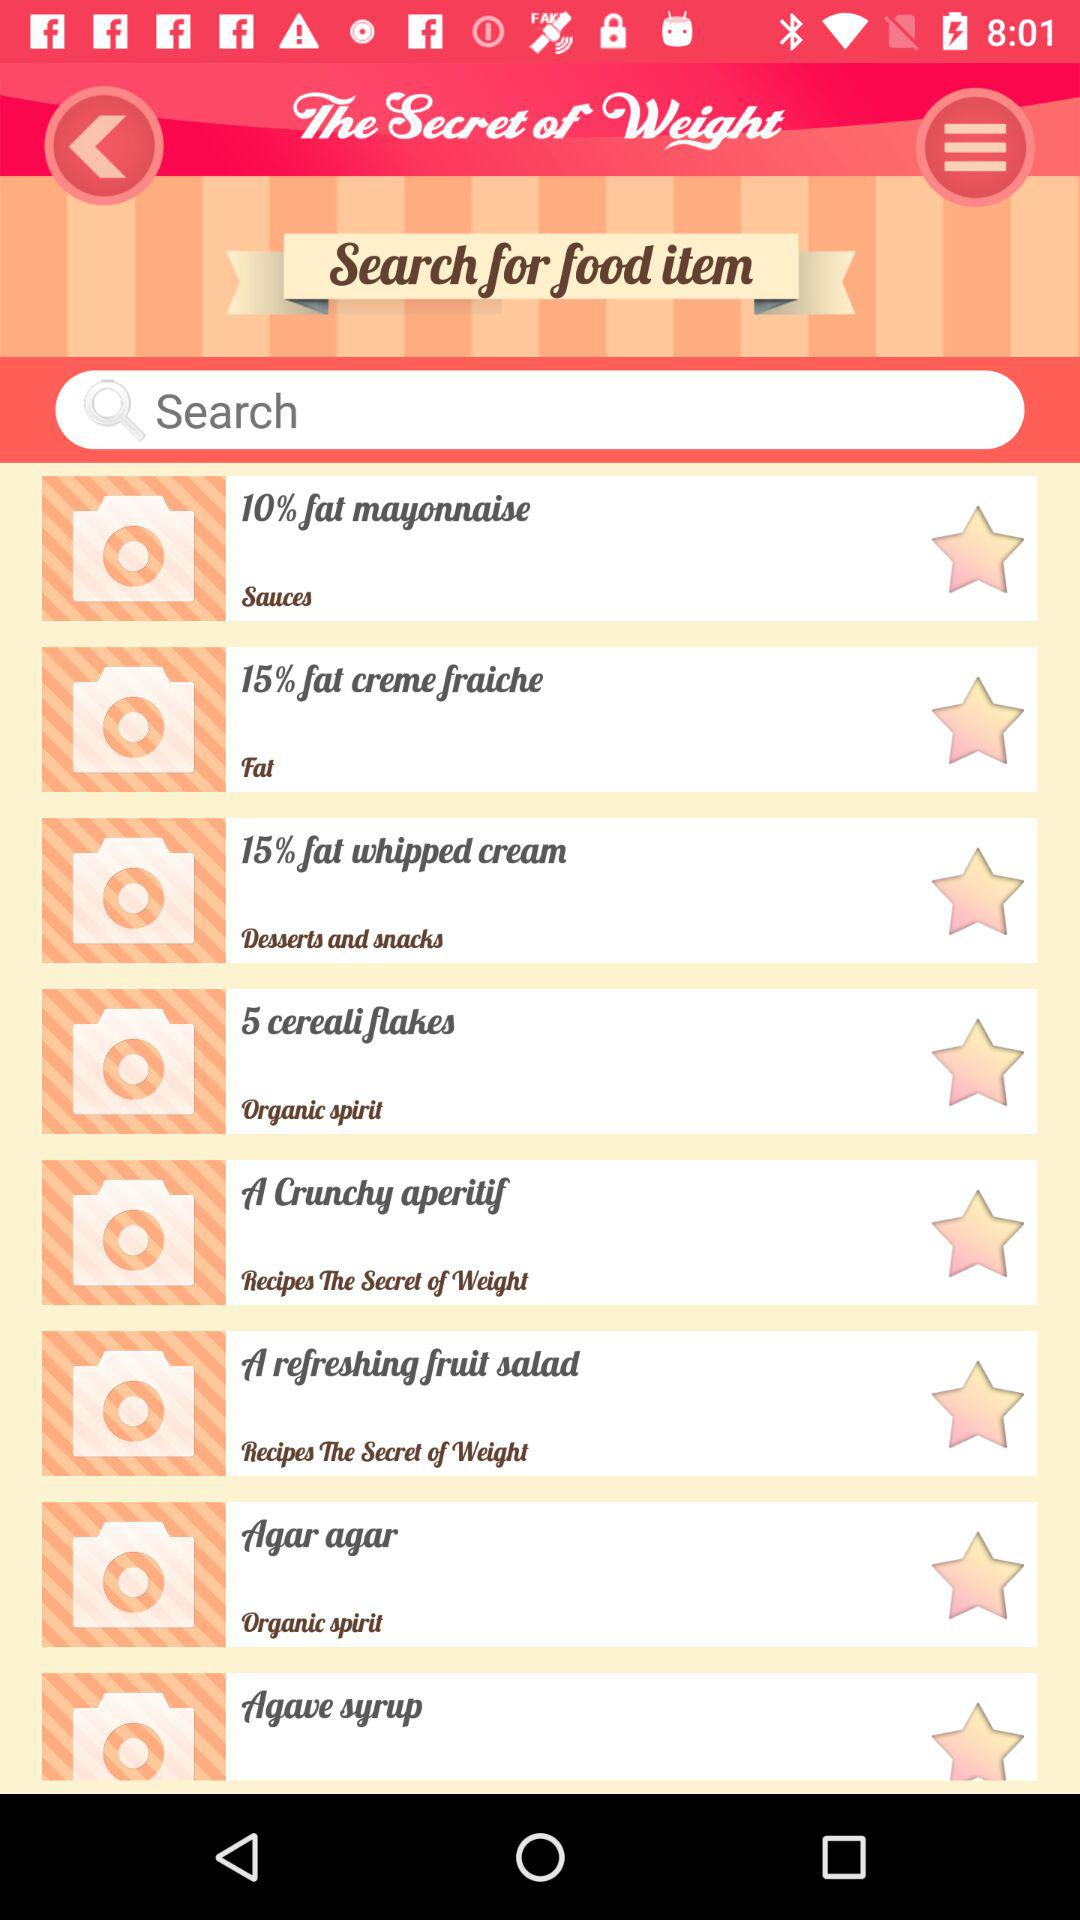How many of the food items are in the category 'Sauces'?
Answer the question using a single word or phrase. 1 